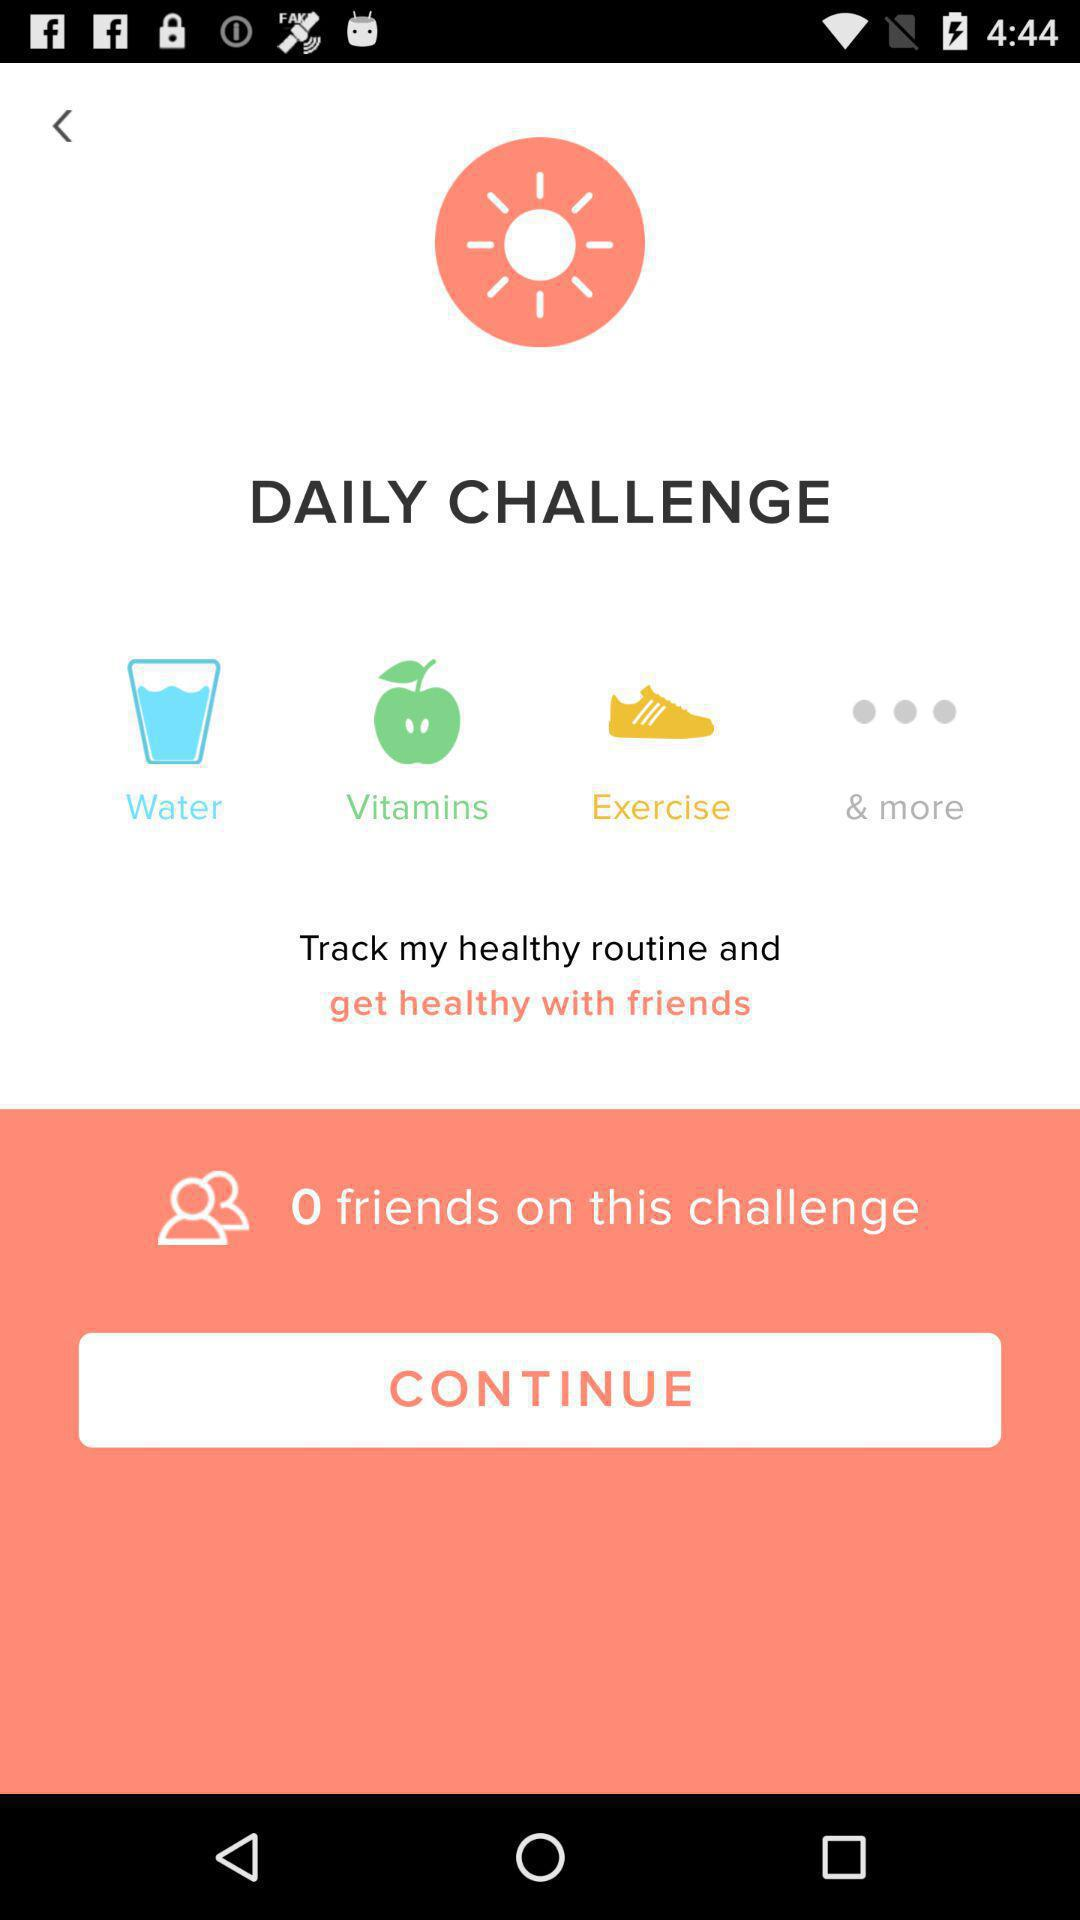How many friends are there on this challenge? There are 0 friends on this challenge. 